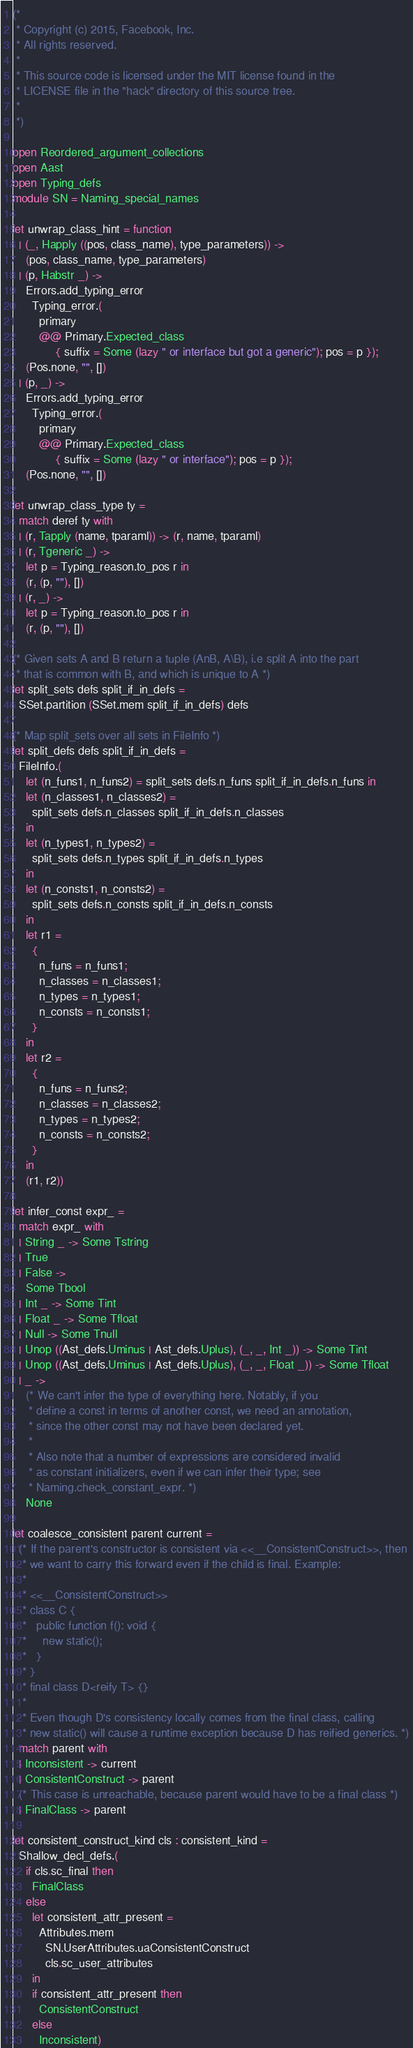Convert code to text. <code><loc_0><loc_0><loc_500><loc_500><_OCaml_>(*
 * Copyright (c) 2015, Facebook, Inc.
 * All rights reserved.
 *
 * This source code is licensed under the MIT license found in the
 * LICENSE file in the "hack" directory of this source tree.
 *
 *)

open Reordered_argument_collections
open Aast
open Typing_defs
module SN = Naming_special_names

let unwrap_class_hint = function
  | (_, Happly ((pos, class_name), type_parameters)) ->
    (pos, class_name, type_parameters)
  | (p, Habstr _) ->
    Errors.add_typing_error
      Typing_error.(
        primary
        @@ Primary.Expected_class
             { suffix = Some (lazy " or interface but got a generic"); pos = p });
    (Pos.none, "", [])
  | (p, _) ->
    Errors.add_typing_error
      Typing_error.(
        primary
        @@ Primary.Expected_class
             { suffix = Some (lazy " or interface"); pos = p });
    (Pos.none, "", [])

let unwrap_class_type ty =
  match deref ty with
  | (r, Tapply (name, tparaml)) -> (r, name, tparaml)
  | (r, Tgeneric _) ->
    let p = Typing_reason.to_pos r in
    (r, (p, ""), [])
  | (r, _) ->
    let p = Typing_reason.to_pos r in
    (r, (p, ""), [])

(* Given sets A and B return a tuple (AnB, A\B), i.e split A into the part
 * that is common with B, and which is unique to A *)
let split_sets defs split_if_in_defs =
  SSet.partition (SSet.mem split_if_in_defs) defs

(* Map split_sets over all sets in FileInfo *)
let split_defs defs split_if_in_defs =
  FileInfo.(
    let (n_funs1, n_funs2) = split_sets defs.n_funs split_if_in_defs.n_funs in
    let (n_classes1, n_classes2) =
      split_sets defs.n_classes split_if_in_defs.n_classes
    in
    let (n_types1, n_types2) =
      split_sets defs.n_types split_if_in_defs.n_types
    in
    let (n_consts1, n_consts2) =
      split_sets defs.n_consts split_if_in_defs.n_consts
    in
    let r1 =
      {
        n_funs = n_funs1;
        n_classes = n_classes1;
        n_types = n_types1;
        n_consts = n_consts1;
      }
    in
    let r2 =
      {
        n_funs = n_funs2;
        n_classes = n_classes2;
        n_types = n_types2;
        n_consts = n_consts2;
      }
    in
    (r1, r2))

let infer_const expr_ =
  match expr_ with
  | String _ -> Some Tstring
  | True
  | False ->
    Some Tbool
  | Int _ -> Some Tint
  | Float _ -> Some Tfloat
  | Null -> Some Tnull
  | Unop ((Ast_defs.Uminus | Ast_defs.Uplus), (_, _, Int _)) -> Some Tint
  | Unop ((Ast_defs.Uminus | Ast_defs.Uplus), (_, _, Float _)) -> Some Tfloat
  | _ ->
    (* We can't infer the type of everything here. Notably, if you
     * define a const in terms of another const, we need an annotation,
     * since the other const may not have been declared yet.
     *
     * Also note that a number of expressions are considered invalid
     * as constant initializers, even if we can infer their type; see
     * Naming.check_constant_expr. *)
    None

let coalesce_consistent parent current =
  (* If the parent's constructor is consistent via <<__ConsistentConstruct>>, then
   * we want to carry this forward even if the child is final. Example:
   *
   * <<__ConsistentConstruct>>
   * class C {
   *   public function f(): void {
   *     new static();
   *   }
   * }
   * final class D<reify T> {}
   *
   * Even though D's consistency locally comes from the final class, calling
   * new static() will cause a runtime exception because D has reified generics. *)
  match parent with
  | Inconsistent -> current
  | ConsistentConstruct -> parent
  (* This case is unreachable, because parent would have to be a final class *)
  | FinalClass -> parent

let consistent_construct_kind cls : consistent_kind =
  Shallow_decl_defs.(
    if cls.sc_final then
      FinalClass
    else
      let consistent_attr_present =
        Attributes.mem
          SN.UserAttributes.uaConsistentConstruct
          cls.sc_user_attributes
      in
      if consistent_attr_present then
        ConsistentConstruct
      else
        Inconsistent)
</code> 